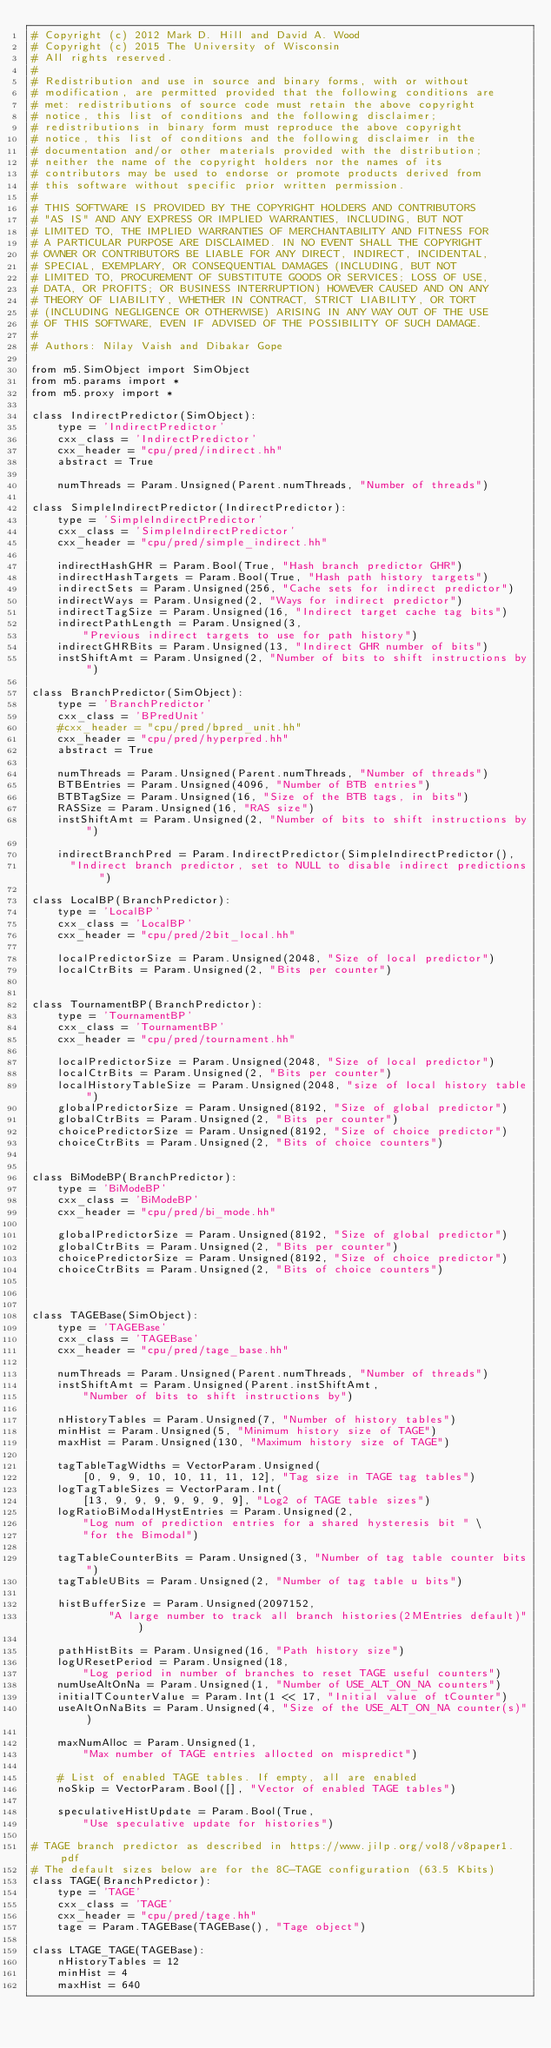<code> <loc_0><loc_0><loc_500><loc_500><_Python_># Copyright (c) 2012 Mark D. Hill and David A. Wood
# Copyright (c) 2015 The University of Wisconsin
# All rights reserved.
#
# Redistribution and use in source and binary forms, with or without
# modification, are permitted provided that the following conditions are
# met: redistributions of source code must retain the above copyright
# notice, this list of conditions and the following disclaimer;
# redistributions in binary form must reproduce the above copyright
# notice, this list of conditions and the following disclaimer in the
# documentation and/or other materials provided with the distribution;
# neither the name of the copyright holders nor the names of its
# contributors may be used to endorse or promote products derived from
# this software without specific prior written permission.
#
# THIS SOFTWARE IS PROVIDED BY THE COPYRIGHT HOLDERS AND CONTRIBUTORS
# "AS IS" AND ANY EXPRESS OR IMPLIED WARRANTIES, INCLUDING, BUT NOT
# LIMITED TO, THE IMPLIED WARRANTIES OF MERCHANTABILITY AND FITNESS FOR
# A PARTICULAR PURPOSE ARE DISCLAIMED. IN NO EVENT SHALL THE COPYRIGHT
# OWNER OR CONTRIBUTORS BE LIABLE FOR ANY DIRECT, INDIRECT, INCIDENTAL,
# SPECIAL, EXEMPLARY, OR CONSEQUENTIAL DAMAGES (INCLUDING, BUT NOT
# LIMITED TO, PROCUREMENT OF SUBSTITUTE GOODS OR SERVICES; LOSS OF USE,
# DATA, OR PROFITS; OR BUSINESS INTERRUPTION) HOWEVER CAUSED AND ON ANY
# THEORY OF LIABILITY, WHETHER IN CONTRACT, STRICT LIABILITY, OR TORT
# (INCLUDING NEGLIGENCE OR OTHERWISE) ARISING IN ANY WAY OUT OF THE USE
# OF THIS SOFTWARE, EVEN IF ADVISED OF THE POSSIBILITY OF SUCH DAMAGE.
#
# Authors: Nilay Vaish and Dibakar Gope

from m5.SimObject import SimObject
from m5.params import *
from m5.proxy import *

class IndirectPredictor(SimObject):
    type = 'IndirectPredictor'
    cxx_class = 'IndirectPredictor'
    cxx_header = "cpu/pred/indirect.hh"
    abstract = True

    numThreads = Param.Unsigned(Parent.numThreads, "Number of threads")

class SimpleIndirectPredictor(IndirectPredictor):
    type = 'SimpleIndirectPredictor'
    cxx_class = 'SimpleIndirectPredictor'
    cxx_header = "cpu/pred/simple_indirect.hh"

    indirectHashGHR = Param.Bool(True, "Hash branch predictor GHR")
    indirectHashTargets = Param.Bool(True, "Hash path history targets")
    indirectSets = Param.Unsigned(256, "Cache sets for indirect predictor")
    indirectWays = Param.Unsigned(2, "Ways for indirect predictor")
    indirectTagSize = Param.Unsigned(16, "Indirect target cache tag bits")
    indirectPathLength = Param.Unsigned(3,
        "Previous indirect targets to use for path history")
    indirectGHRBits = Param.Unsigned(13, "Indirect GHR number of bits")
    instShiftAmt = Param.Unsigned(2, "Number of bits to shift instructions by")

class BranchPredictor(SimObject):
    type = 'BranchPredictor'
    cxx_class = 'BPredUnit'
    #cxx_header = "cpu/pred/bpred_unit.hh"
    cxx_header = "cpu/pred/hyperpred.hh"
    abstract = True

    numThreads = Param.Unsigned(Parent.numThreads, "Number of threads")
    BTBEntries = Param.Unsigned(4096, "Number of BTB entries")
    BTBTagSize = Param.Unsigned(16, "Size of the BTB tags, in bits")
    RASSize = Param.Unsigned(16, "RAS size")
    instShiftAmt = Param.Unsigned(2, "Number of bits to shift instructions by")

    indirectBranchPred = Param.IndirectPredictor(SimpleIndirectPredictor(),
      "Indirect branch predictor, set to NULL to disable indirect predictions")

class LocalBP(BranchPredictor):
    type = 'LocalBP'
    cxx_class = 'LocalBP'
    cxx_header = "cpu/pred/2bit_local.hh"

    localPredictorSize = Param.Unsigned(2048, "Size of local predictor")
    localCtrBits = Param.Unsigned(2, "Bits per counter")


class TournamentBP(BranchPredictor):
    type = 'TournamentBP'
    cxx_class = 'TournamentBP'
    cxx_header = "cpu/pred/tournament.hh"

    localPredictorSize = Param.Unsigned(2048, "Size of local predictor")
    localCtrBits = Param.Unsigned(2, "Bits per counter")
    localHistoryTableSize = Param.Unsigned(2048, "size of local history table")
    globalPredictorSize = Param.Unsigned(8192, "Size of global predictor")
    globalCtrBits = Param.Unsigned(2, "Bits per counter")
    choicePredictorSize = Param.Unsigned(8192, "Size of choice predictor")
    choiceCtrBits = Param.Unsigned(2, "Bits of choice counters")


class BiModeBP(BranchPredictor):
    type = 'BiModeBP'
    cxx_class = 'BiModeBP'
    cxx_header = "cpu/pred/bi_mode.hh"

    globalPredictorSize = Param.Unsigned(8192, "Size of global predictor")
    globalCtrBits = Param.Unsigned(2, "Bits per counter")
    choicePredictorSize = Param.Unsigned(8192, "Size of choice predictor")
    choiceCtrBits = Param.Unsigned(2, "Bits of choice counters")



class TAGEBase(SimObject):
    type = 'TAGEBase'
    cxx_class = 'TAGEBase'
    cxx_header = "cpu/pred/tage_base.hh"

    numThreads = Param.Unsigned(Parent.numThreads, "Number of threads")
    instShiftAmt = Param.Unsigned(Parent.instShiftAmt,
        "Number of bits to shift instructions by")

    nHistoryTables = Param.Unsigned(7, "Number of history tables")
    minHist = Param.Unsigned(5, "Minimum history size of TAGE")
    maxHist = Param.Unsigned(130, "Maximum history size of TAGE")

    tagTableTagWidths = VectorParam.Unsigned(
        [0, 9, 9, 10, 10, 11, 11, 12], "Tag size in TAGE tag tables")
    logTagTableSizes = VectorParam.Int(
        [13, 9, 9, 9, 9, 9, 9, 9], "Log2 of TAGE table sizes")
    logRatioBiModalHystEntries = Param.Unsigned(2,
        "Log num of prediction entries for a shared hysteresis bit " \
        "for the Bimodal")

    tagTableCounterBits = Param.Unsigned(3, "Number of tag table counter bits")
    tagTableUBits = Param.Unsigned(2, "Number of tag table u bits")

    histBufferSize = Param.Unsigned(2097152,
            "A large number to track all branch histories(2MEntries default)")

    pathHistBits = Param.Unsigned(16, "Path history size")
    logUResetPeriod = Param.Unsigned(18,
        "Log period in number of branches to reset TAGE useful counters")
    numUseAltOnNa = Param.Unsigned(1, "Number of USE_ALT_ON_NA counters")
    initialTCounterValue = Param.Int(1 << 17, "Initial value of tCounter")
    useAltOnNaBits = Param.Unsigned(4, "Size of the USE_ALT_ON_NA counter(s)")

    maxNumAlloc = Param.Unsigned(1,
        "Max number of TAGE entries allocted on mispredict")

    # List of enabled TAGE tables. If empty, all are enabled
    noSkip = VectorParam.Bool([], "Vector of enabled TAGE tables")

    speculativeHistUpdate = Param.Bool(True,
        "Use speculative update for histories")

# TAGE branch predictor as described in https://www.jilp.org/vol8/v8paper1.pdf
# The default sizes below are for the 8C-TAGE configuration (63.5 Kbits)
class TAGE(BranchPredictor):
    type = 'TAGE'
    cxx_class = 'TAGE'
    cxx_header = "cpu/pred/tage.hh"
    tage = Param.TAGEBase(TAGEBase(), "Tage object")

class LTAGE_TAGE(TAGEBase):
    nHistoryTables = 12
    minHist = 4
    maxHist = 640</code> 